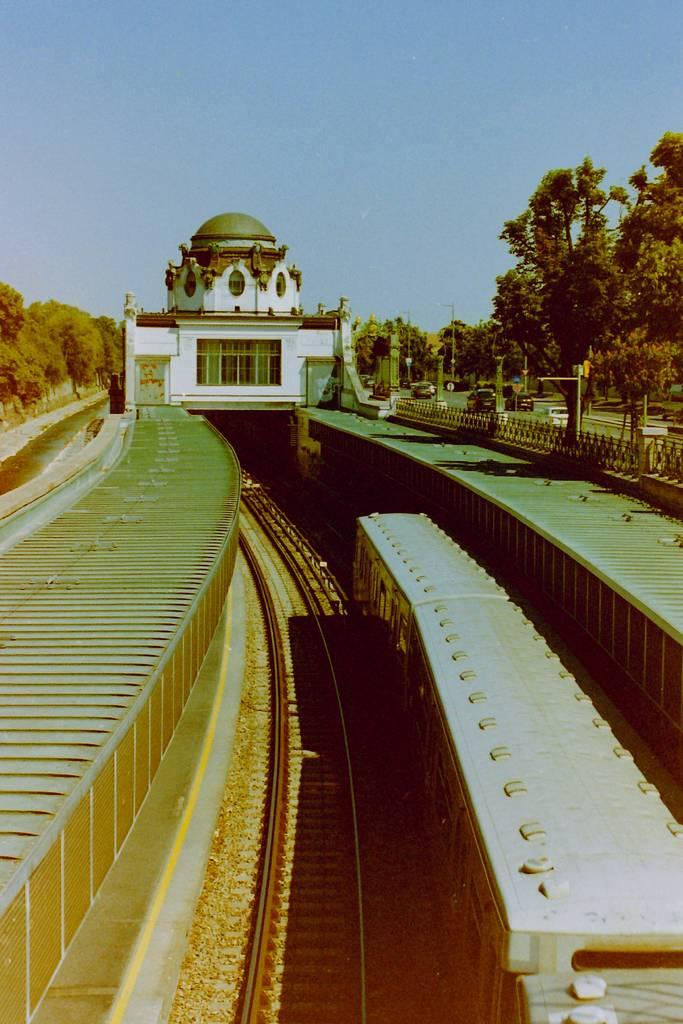What is the main subject of the image? The main subject of the image is a train on the railway track. Can you describe the railway track in the image? There is another railway track in the image. What can be seen in the background of the image? There is a building, trees, vehicles, a road, poles, and the sky visible in the background of the image. What type of pump can be seen in the image? There is no pump present in the image. How many sticks are being used by the dog in the image? There is no dog present in the image, so there are no sticks being used by a dog. 